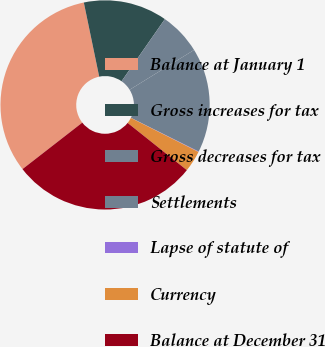Convert chart to OTSL. <chart><loc_0><loc_0><loc_500><loc_500><pie_chart><fcel>Balance at January 1<fcel>Gross increases for tax<fcel>Gross decreases for tax<fcel>Settlements<fcel>Lapse of statute of<fcel>Currency<fcel>Balance at December 31<nl><fcel>32.26%<fcel>12.94%<fcel>6.51%<fcel>16.16%<fcel>0.07%<fcel>3.29%<fcel>28.77%<nl></chart> 